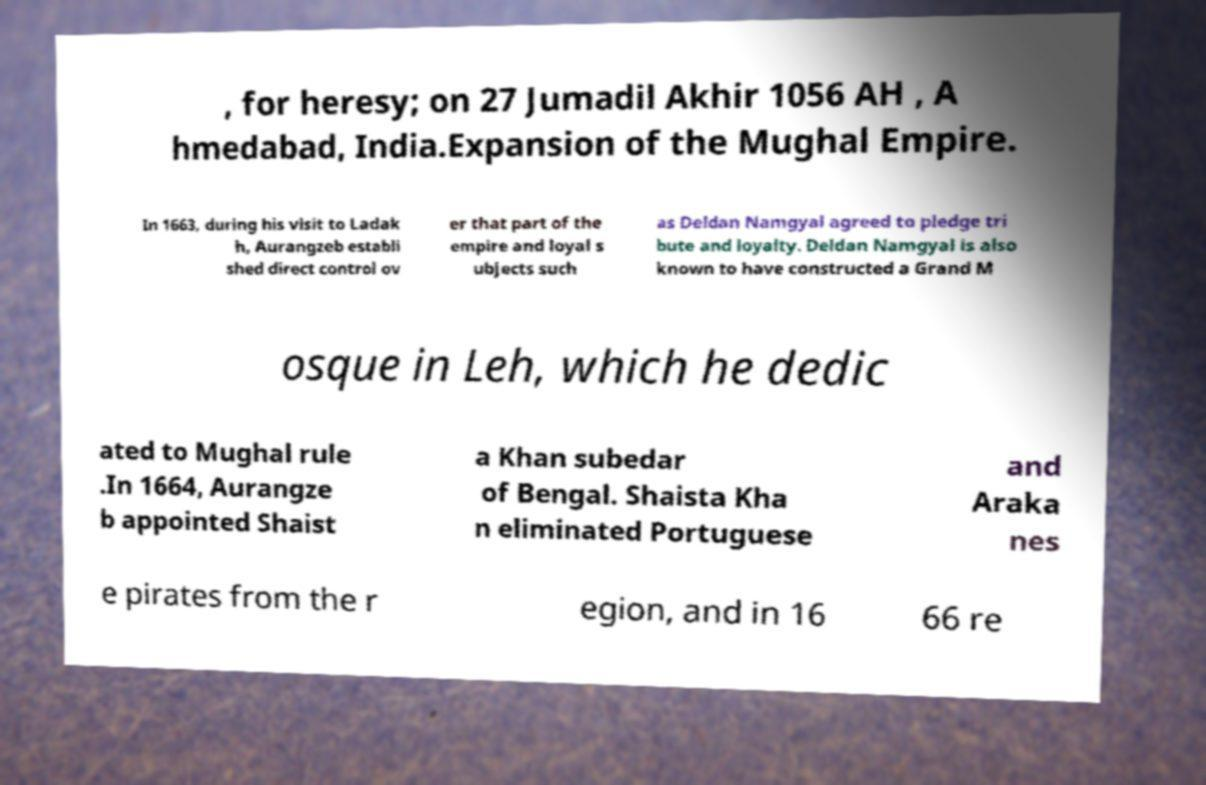Please read and relay the text visible in this image. What does it say? , for heresy; on 27 Jumadil Akhir 1056 AH , A hmedabad, India.Expansion of the Mughal Empire. In 1663, during his visit to Ladak h, Aurangzeb establi shed direct control ov er that part of the empire and loyal s ubjects such as Deldan Namgyal agreed to pledge tri bute and loyalty. Deldan Namgyal is also known to have constructed a Grand M osque in Leh, which he dedic ated to Mughal rule .In 1664, Aurangze b appointed Shaist a Khan subedar of Bengal. Shaista Kha n eliminated Portuguese and Araka nes e pirates from the r egion, and in 16 66 re 